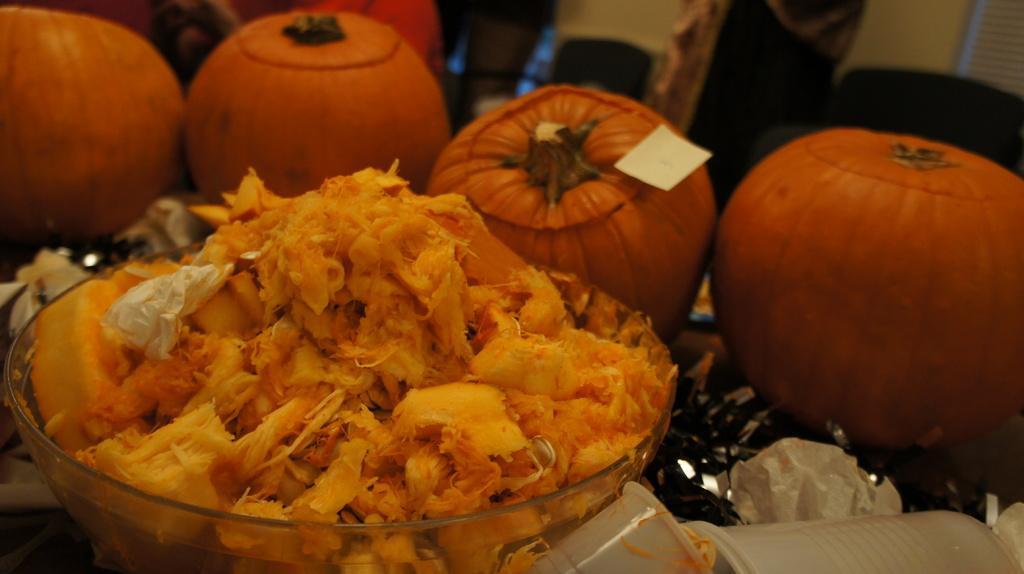In one or two sentences, can you explain what this image depicts? In this picture we can see some food in the bowl. Behind we can see some orange color pumpkins. 